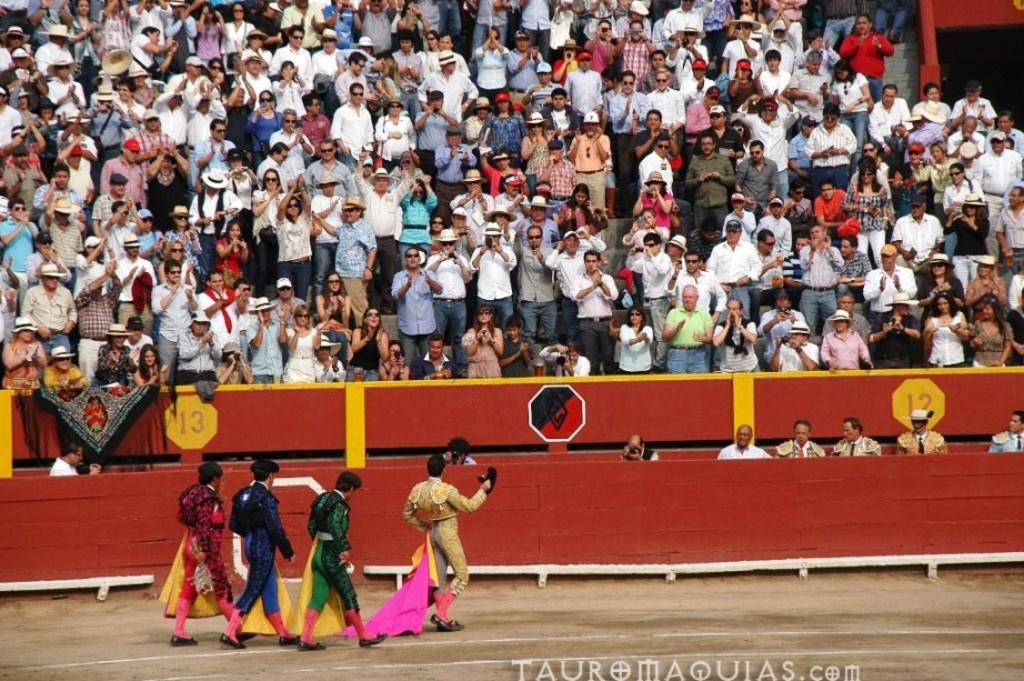In one or two sentences, can you explain what this image depicts? There are four persons in different color dresses, walking on the road and there are white color lines. In the bottom right, there is a watermark. In the background, there are barricades and there are persons. 